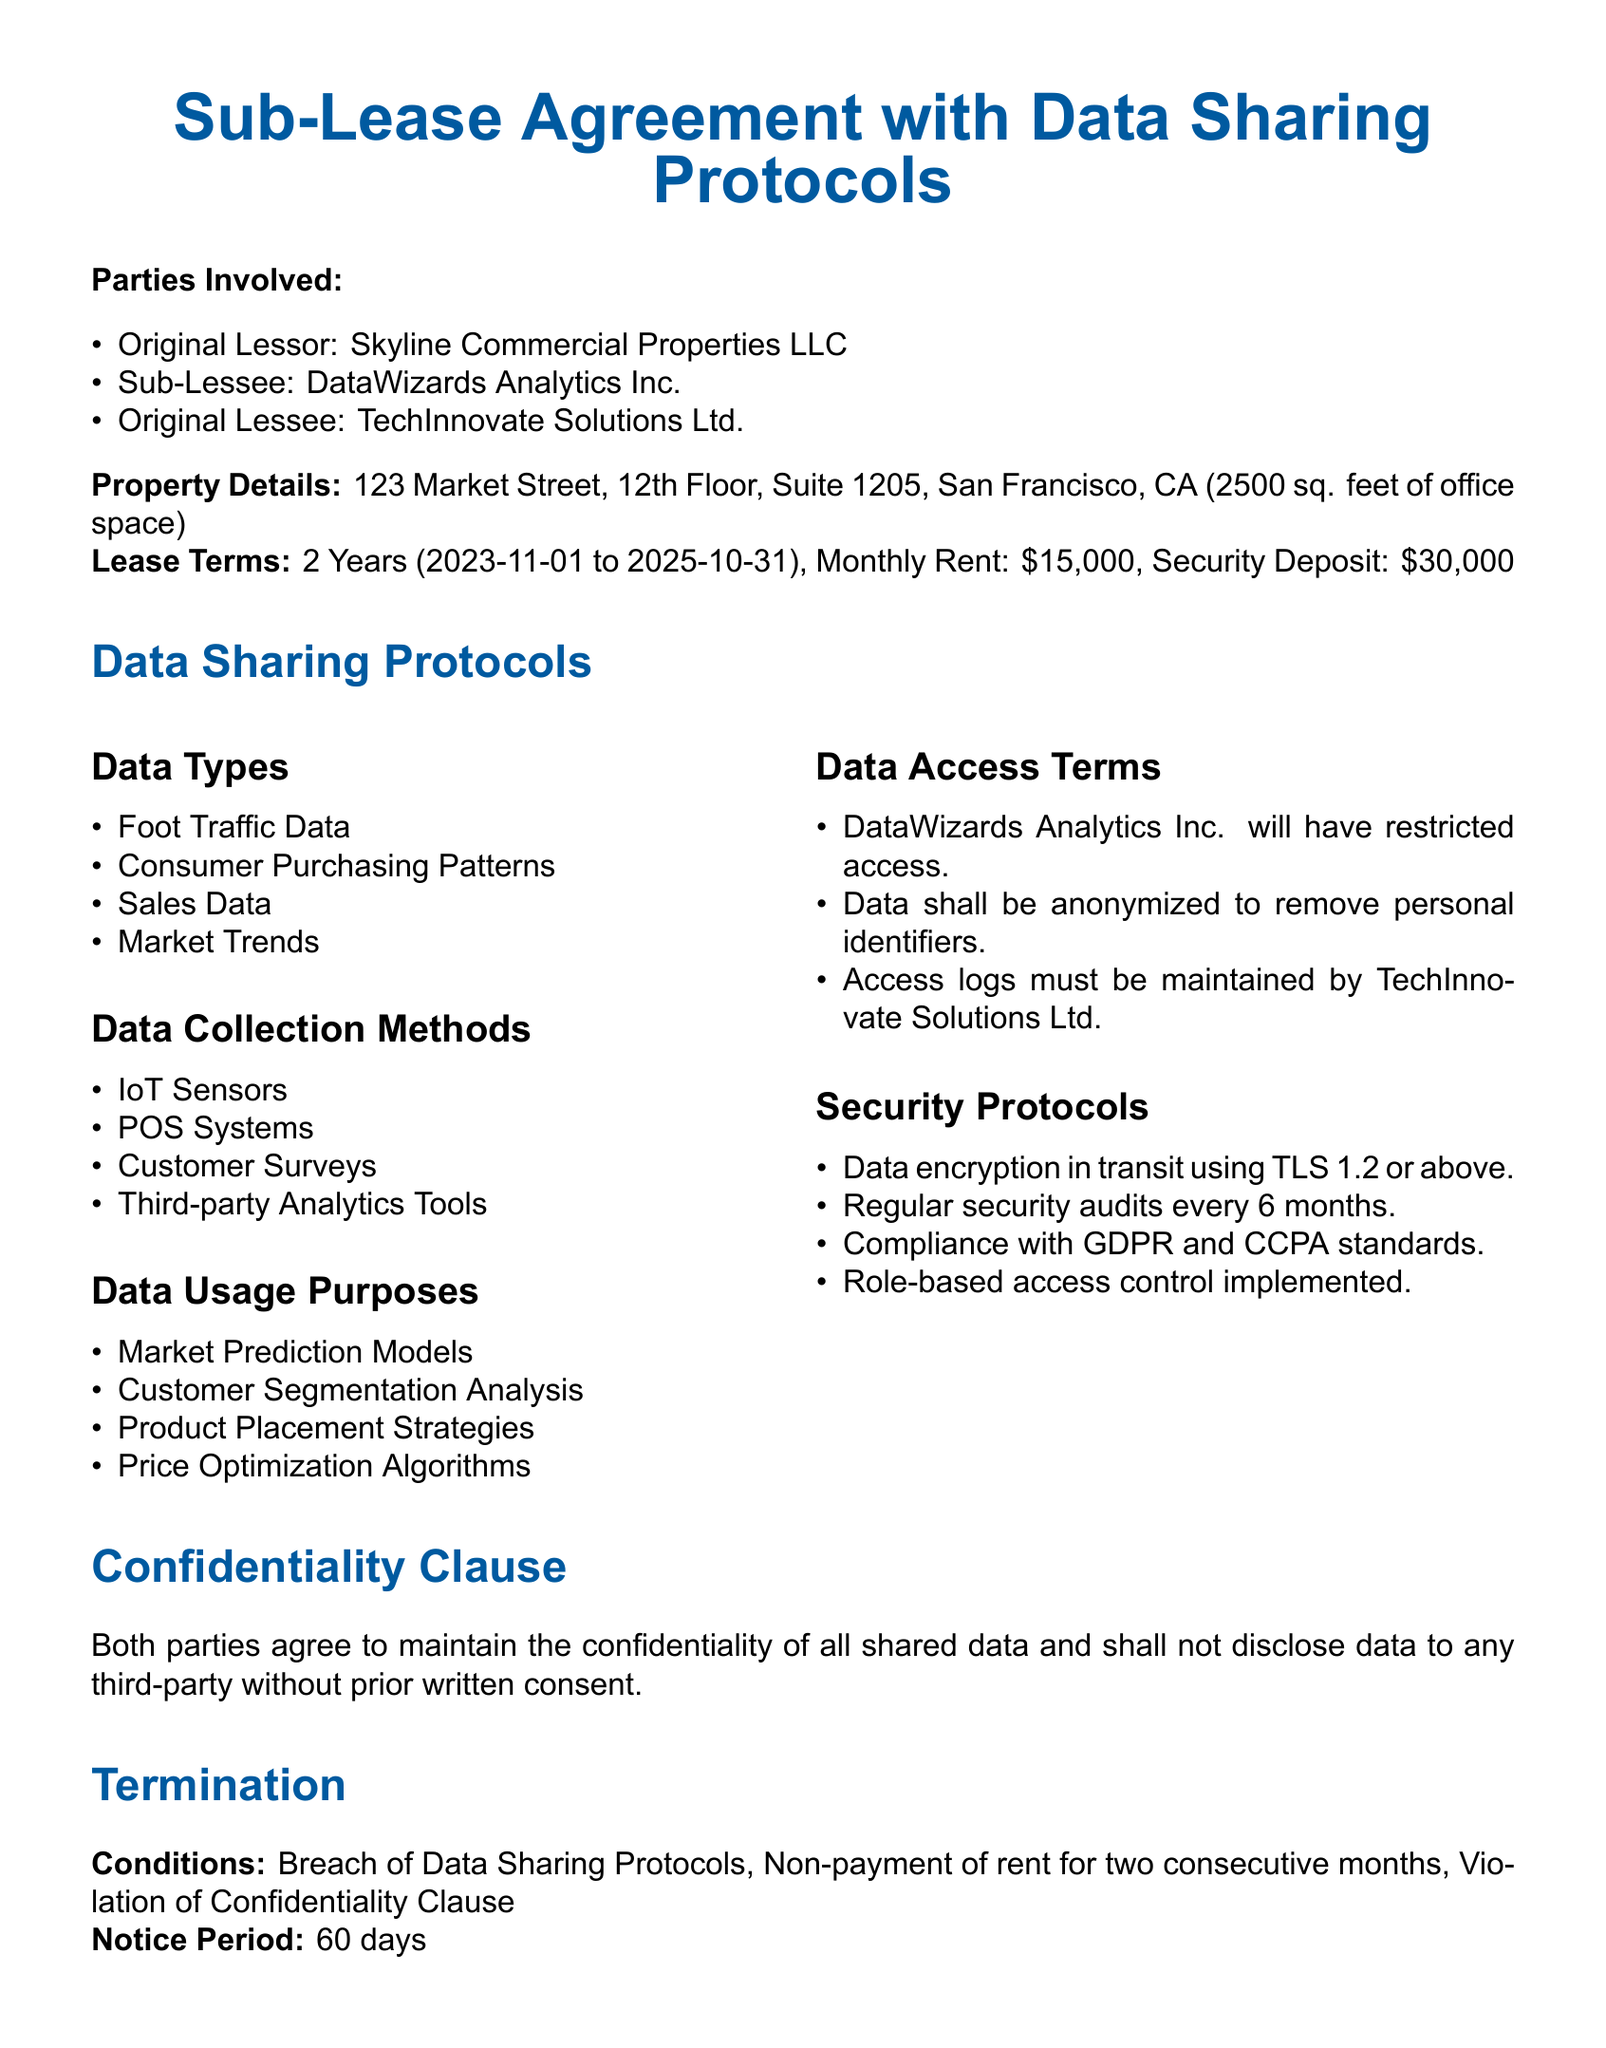what is the name of the original lessor? The original lessor is listed at the beginning of the document as Skyline Commercial Properties LLC.
Answer: Skyline Commercial Properties LLC who is the sub-lessee? The document specifies the sub-lessee as DataWizards Analytics Inc.
Answer: DataWizards Analytics Inc what is the monthly rent agreed upon? The document states the monthly rent is $15,000 as part of the lease terms.
Answer: $15,000 what is the duration of the lease? The lease duration is mentioned in the terms as 2 years, from 2023-11-01 to 2025-10-31.
Answer: 2 years what are the data access terms for DataWizards Analytics Inc.? The document outlines that DataWizards Analytics Inc. will have restricted access to the data.
Answer: restricted access what must be maintained by TechInnovate Solutions Ltd.? According to the data access terms, TechInnovate Solutions Ltd. must maintain access logs.
Answer: access logs how often will security audits occur? The security protocols state that security audits will occur every 6 months.
Answer: every 6 months what is one of the data types listed in the document? The document lists several data types, including Foot Traffic Data as one of them.
Answer: Foot Traffic Data what is the notice period for termination? The termination section specifies that the notice period is 60 days.
Answer: 60 days 